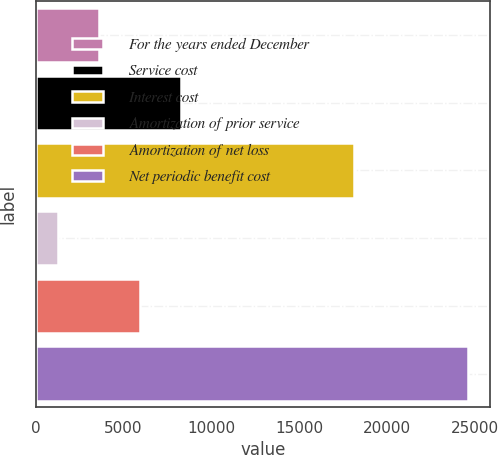Convert chart. <chart><loc_0><loc_0><loc_500><loc_500><bar_chart><fcel>For the years ended December<fcel>Service cost<fcel>Interest cost<fcel>Amortization of prior service<fcel>Amortization of net loss<fcel>Net periodic benefit cost<nl><fcel>3613.5<fcel>8282.5<fcel>18115<fcel>1279<fcel>5948<fcel>24624<nl></chart> 